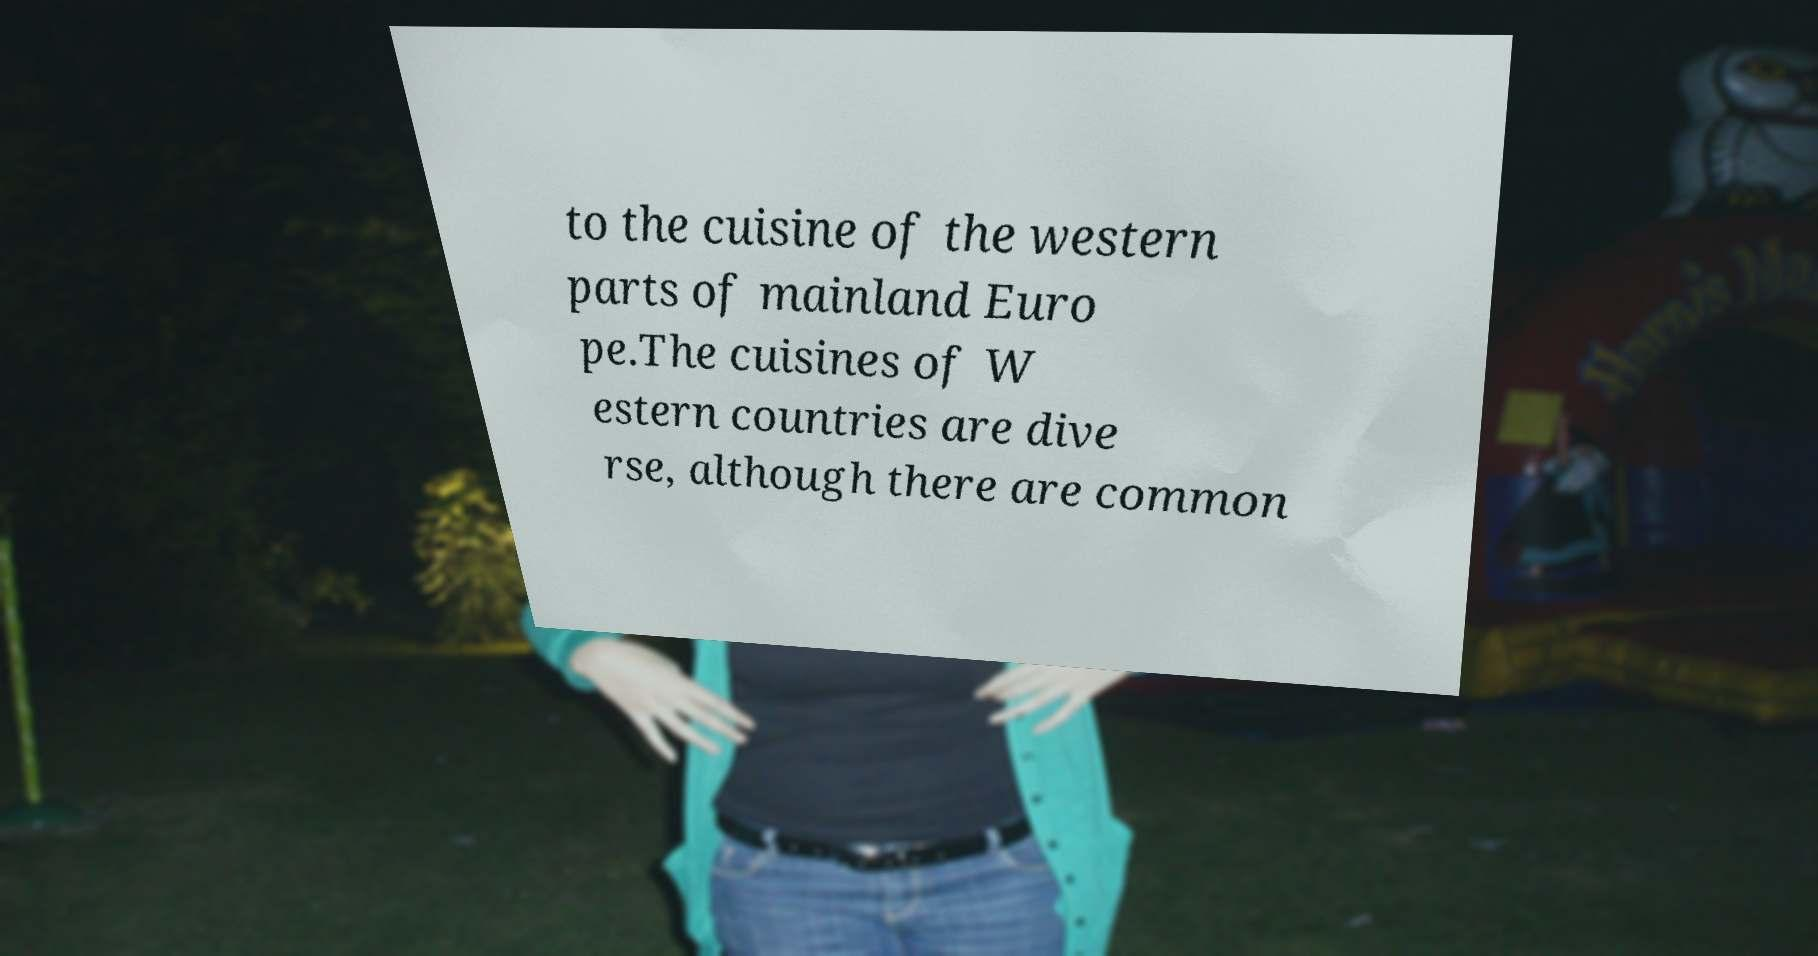Please read and relay the text visible in this image. What does it say? to the cuisine of the western parts of mainland Euro pe.The cuisines of W estern countries are dive rse, although there are common 